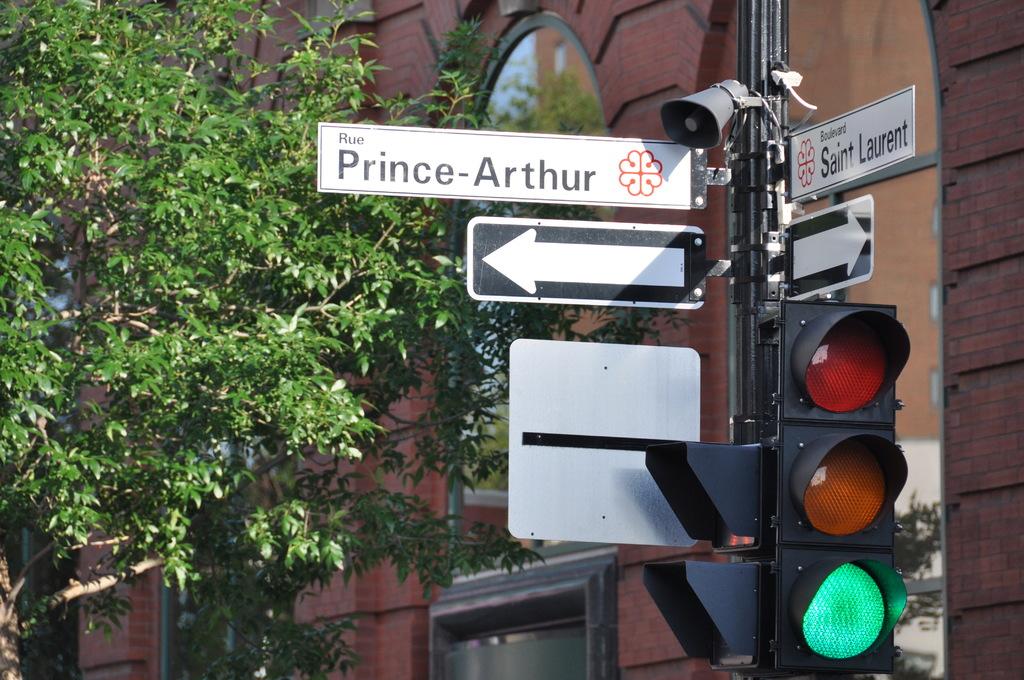What road is this?
Your answer should be very brief. Prince-arthur. Whats street name is on the right sign?
Make the answer very short. Saint laurent. 